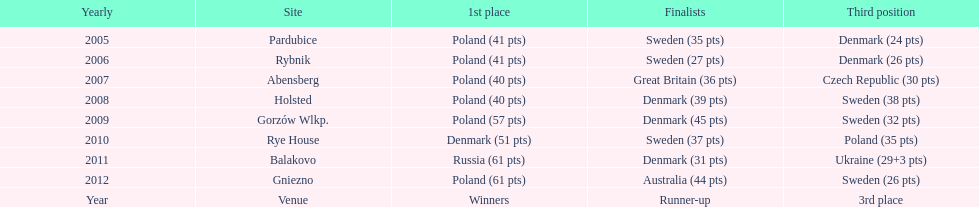Parse the table in full. {'header': ['Yearly', 'Site', '1st place', 'Finalists', 'Third position'], 'rows': [['2005', 'Pardubice', 'Poland (41 pts)', 'Sweden (35 pts)', 'Denmark (24 pts)'], ['2006', 'Rybnik', 'Poland (41 pts)', 'Sweden (27 pts)', 'Denmark (26 pts)'], ['2007', 'Abensberg', 'Poland (40 pts)', 'Great Britain (36 pts)', 'Czech Republic (30 pts)'], ['2008', 'Holsted', 'Poland (40 pts)', 'Denmark (39 pts)', 'Sweden (38 pts)'], ['2009', 'Gorzów Wlkp.', 'Poland (57 pts)', 'Denmark (45 pts)', 'Sweden (32 pts)'], ['2010', 'Rye House', 'Denmark (51 pts)', 'Sweden (37 pts)', 'Poland (35 pts)'], ['2011', 'Balakovo', 'Russia (61 pts)', 'Denmark (31 pts)', 'Ukraine (29+3 pts)'], ['2012', 'Gniezno', 'Poland (61 pts)', 'Australia (44 pts)', 'Sweden (26 pts)'], ['Year', 'Venue', 'Winners', 'Runner-up', '3rd place']]} What was the last year 3rd place finished with less than 25 points? 2005. 